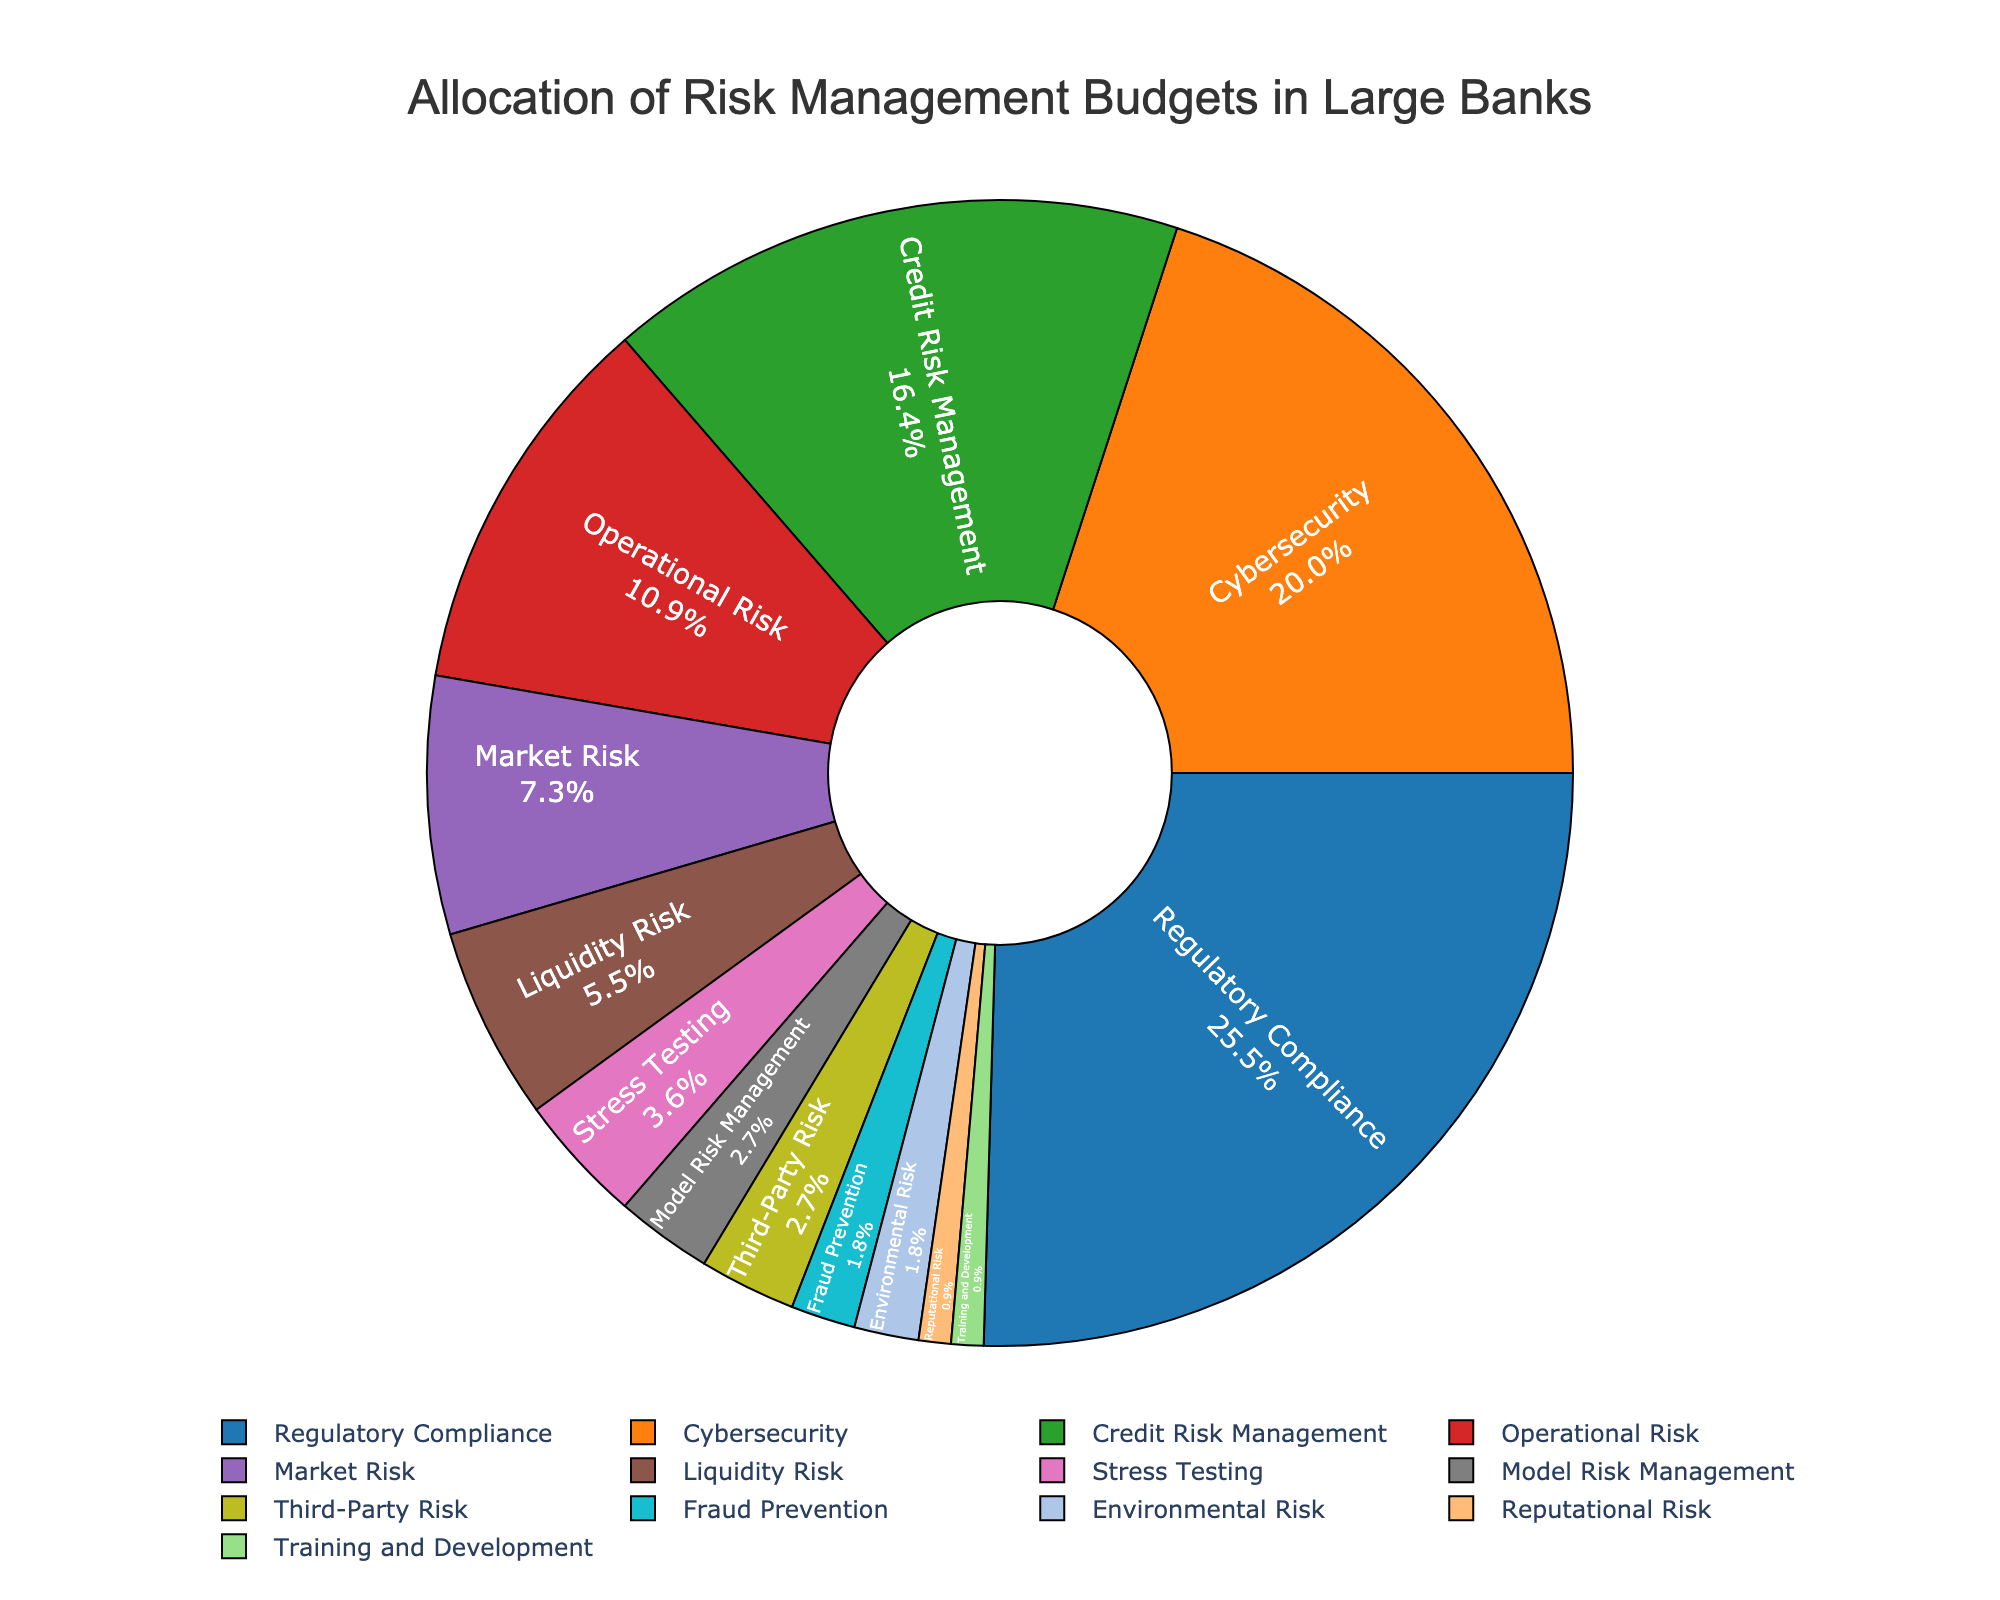Which category receives the highest allocation in risk management budgets? From the pie chart, identify the category with the largest slice. Regulatory Compliance is the largest slice.
Answer: Regulatory Compliance Which category has the smallest budget allocation? Observe the smallest slice in the pie chart. The smallest slice belongs to Reputational Risk and Training and Development, both at 1%.
Answer: Reputational Risk and Training and Development What is the combined allocation percentage for Cybersecurity and Credit Risk Management? Locate the slices for Cybersecurity and Credit Risk Management in the pie chart and sum their percentages: 22% + 18% = 40%.
Answer: 40% How does the allocation for Liquidity Risk compare to that for Market Risk? Find the slices for Liquidity Risk and Market Risk and compare their percentages. Liquidity Risk is 6%, while Market Risk is 8%. Liquidity Risk is less than Market Risk.
Answer: Liquidity Risk is less than Market Risk How much more is allocated to Regulatory Compliance than to Cybersecurity? Find the slices for Regulatory Compliance and Cybersecurity and calculate the difference: 28% - 22% = 6%.
Answer: 6% What is the total allocation for Operational Risk, Market Risk, and Liquidity Risk combined? Locate the slices for Operational Risk, Market Risk, and Liquidity Risk and sum their percentages: 12% + 8% + 6% = 26%.
Answer: 26% Which category has a budget closest in percentage to Model Risk Management? Observe the pie chart and find the category with a slice close to Model Risk Management's 3%. Third-Party Risk also has 3%.
Answer: Third-Party Risk If the allocation for Credit Risk Management doubled, would it surpass Regulatory Compliance? Double the percentage of Credit Risk Management: 2 * 18% = 36%. Compare it with Regulatory Compliance's 28%. Yes, it would surpass.
Answer: Yes What percentage of the budget is allocated to Environmental Risk and Fraud Prevention combined? Combine the percentages of Environmental Risk and Fraud Prevention: 2% + 2% = 4%.
Answer: 4% Rank the categories Cybersecurity, Operational Risk, and Stress Testing in descending order of their budget allocations. Locate the slices for Cybersecurity, Operational Risk, and Stress Testing and order them by their percentages: Cybersecurity (22%), Operational Risk (12%), Stress Testing (4%).
Answer: Cybersecurity, Operational Risk, Stress Testing 